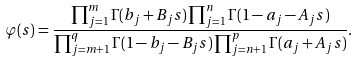<formula> <loc_0><loc_0><loc_500><loc_500>\varphi ( s ) = \frac { \prod _ { j = 1 } ^ { m } \Gamma ( b _ { j } + B _ { j } s ) \prod _ { j = 1 } ^ { n } \Gamma ( 1 - a _ { j } - A _ { j } s ) } { \prod _ { j = m + 1 } ^ { q } \Gamma ( 1 - b _ { j } - B _ { j } s ) \prod _ { j = n + 1 } ^ { p } \Gamma ( a _ { j } + A _ { j } s ) } .</formula> 